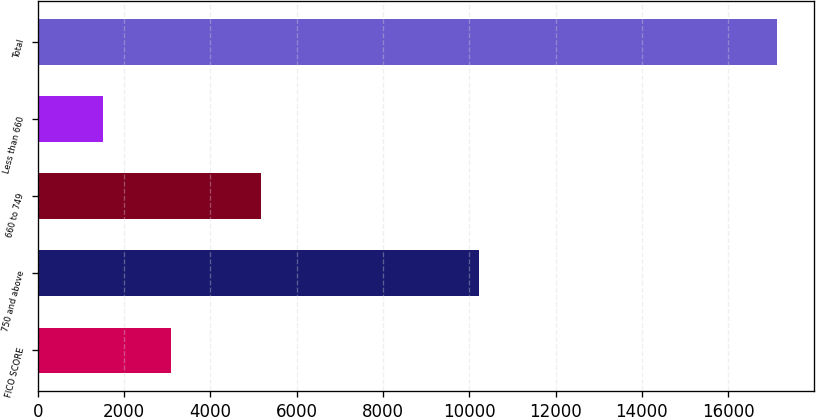Convert chart. <chart><loc_0><loc_0><loc_500><loc_500><bar_chart><fcel>FICO SCORE<fcel>750 and above<fcel>660 to 749<fcel>Less than 660<fcel>Total<nl><fcel>3080.5<fcel>10226<fcel>5181<fcel>1519<fcel>17134<nl></chart> 